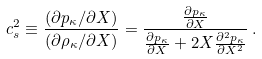Convert formula to latex. <formula><loc_0><loc_0><loc_500><loc_500>c _ { s } ^ { 2 } \equiv \frac { ( \partial p _ { \kappa } / \partial X ) } { ( \partial \rho _ { \kappa } / \partial X ) } = \frac { \frac { \partial p _ { \kappa } } { \partial X } } { \frac { \partial p _ { \kappa } } { \partial X } + 2 X \frac { \partial ^ { 2 } p _ { \kappa } } { \partial X ^ { 2 } } } \, .</formula> 